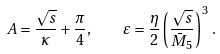<formula> <loc_0><loc_0><loc_500><loc_500>A = \frac { \sqrt { s } } { \kappa } + \frac { \pi } { 4 } , \quad \varepsilon = \frac { \eta } { 2 } \left ( \frac { \sqrt { s } } { \bar { M } _ { 5 } } \right ) ^ { 3 } \, .</formula> 